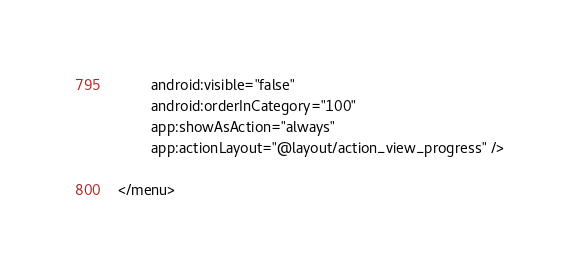Convert code to text. <code><loc_0><loc_0><loc_500><loc_500><_XML_>        android:visible="false"
        android:orderInCategory="100"
        app:showAsAction="always"
        app:actionLayout="@layout/action_view_progress" />

</menu></code> 